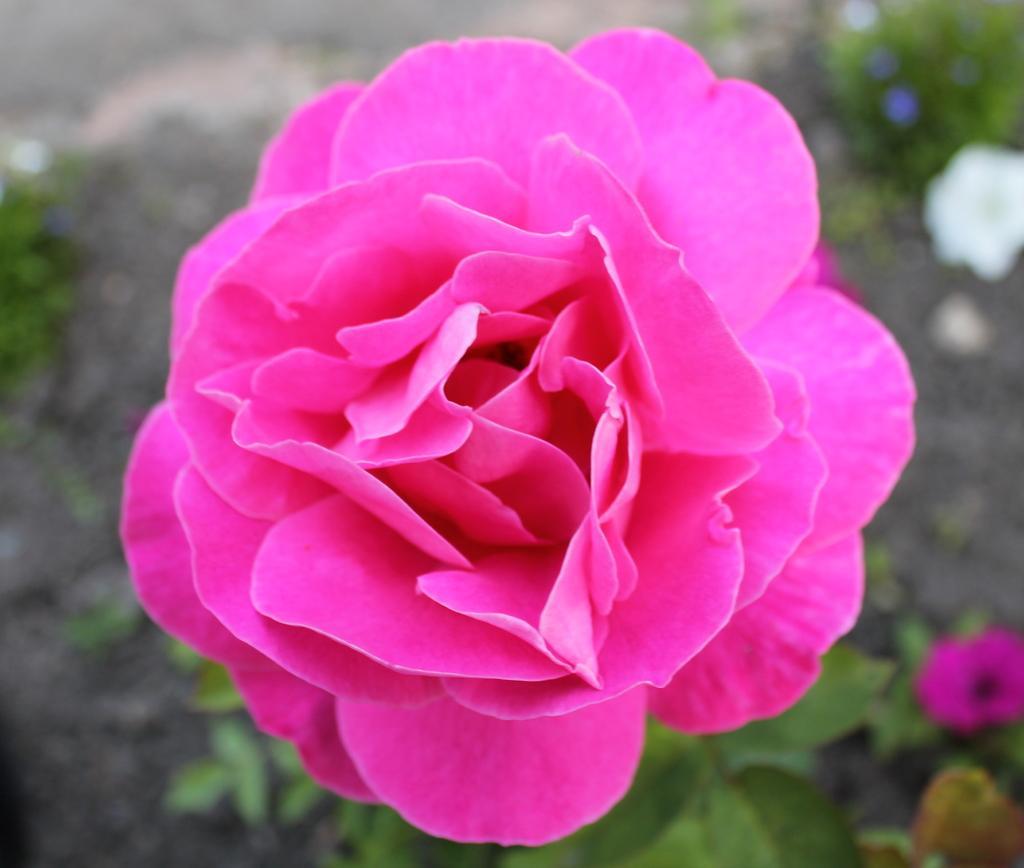Please provide a concise description of this image. In the image we can see some flowers and plants. 